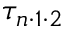<formula> <loc_0><loc_0><loc_500><loc_500>\tau _ { n \cdot 1 \cdot 2 }</formula> 